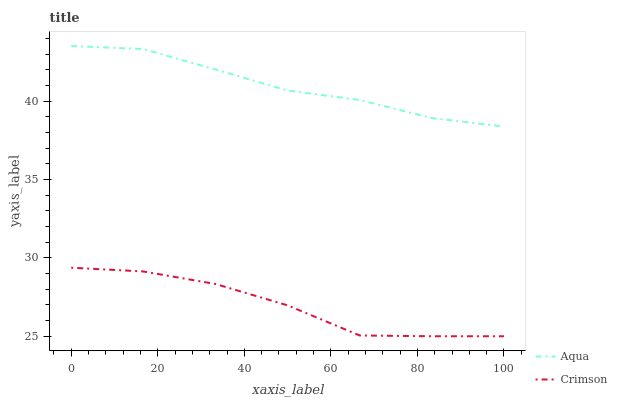Does Crimson have the minimum area under the curve?
Answer yes or no. Yes. Does Aqua have the maximum area under the curve?
Answer yes or no. Yes. Does Aqua have the minimum area under the curve?
Answer yes or no. No. Is Aqua the smoothest?
Answer yes or no. Yes. Is Crimson the roughest?
Answer yes or no. Yes. Is Aqua the roughest?
Answer yes or no. No. Does Crimson have the lowest value?
Answer yes or no. Yes. Does Aqua have the lowest value?
Answer yes or no. No. Does Aqua have the highest value?
Answer yes or no. Yes. Is Crimson less than Aqua?
Answer yes or no. Yes. Is Aqua greater than Crimson?
Answer yes or no. Yes. Does Crimson intersect Aqua?
Answer yes or no. No. 